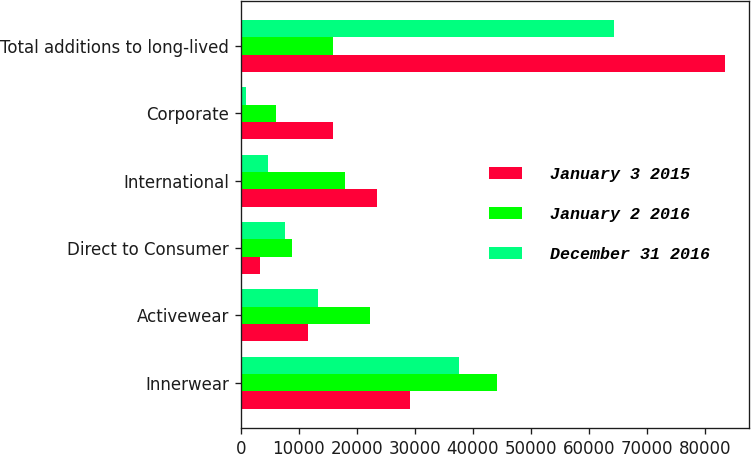Convert chart. <chart><loc_0><loc_0><loc_500><loc_500><stacked_bar_chart><ecel><fcel>Innerwear<fcel>Activewear<fcel>Direct to Consumer<fcel>International<fcel>Corporate<fcel>Total additions to long-lived<nl><fcel>January 3 2015<fcel>29119<fcel>11518<fcel>3312<fcel>23520<fcel>15930<fcel>83399<nl><fcel>January 2 2016<fcel>44183<fcel>22331<fcel>8802<fcel>18022<fcel>6037<fcel>15930<nl><fcel>December 31 2016<fcel>37641<fcel>13378<fcel>7641<fcel>4737<fcel>914<fcel>64311<nl></chart> 